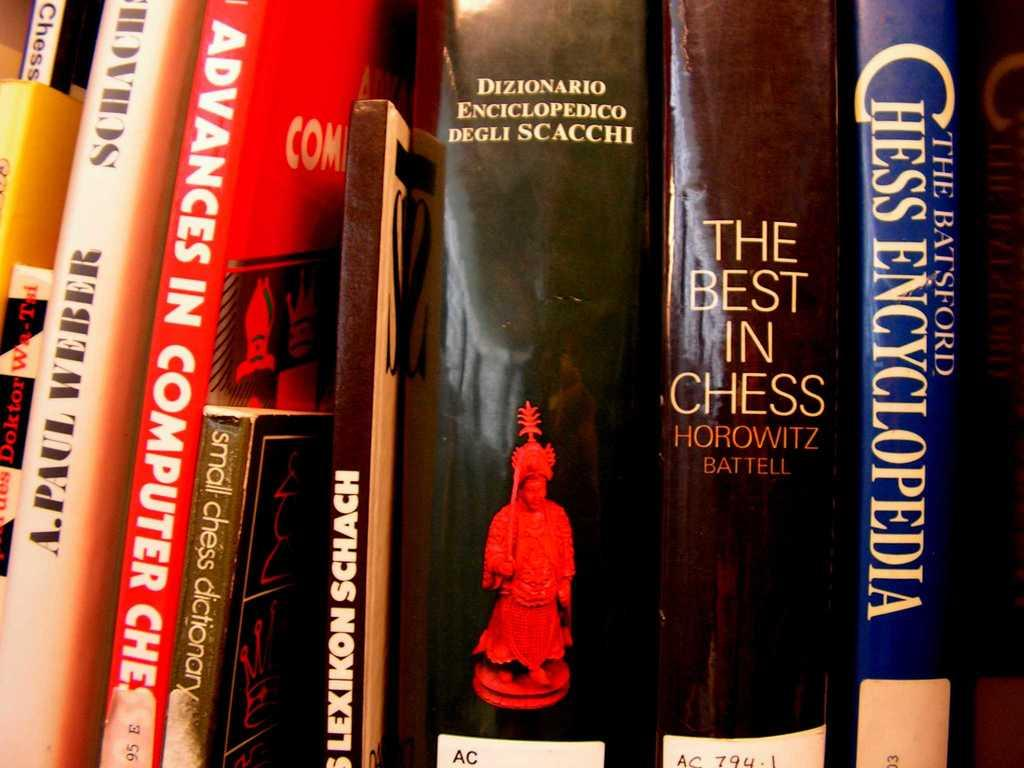<image>
Offer a succinct explanation of the picture presented. a row of books with one titled 'the best in chess' by horowitz battell 